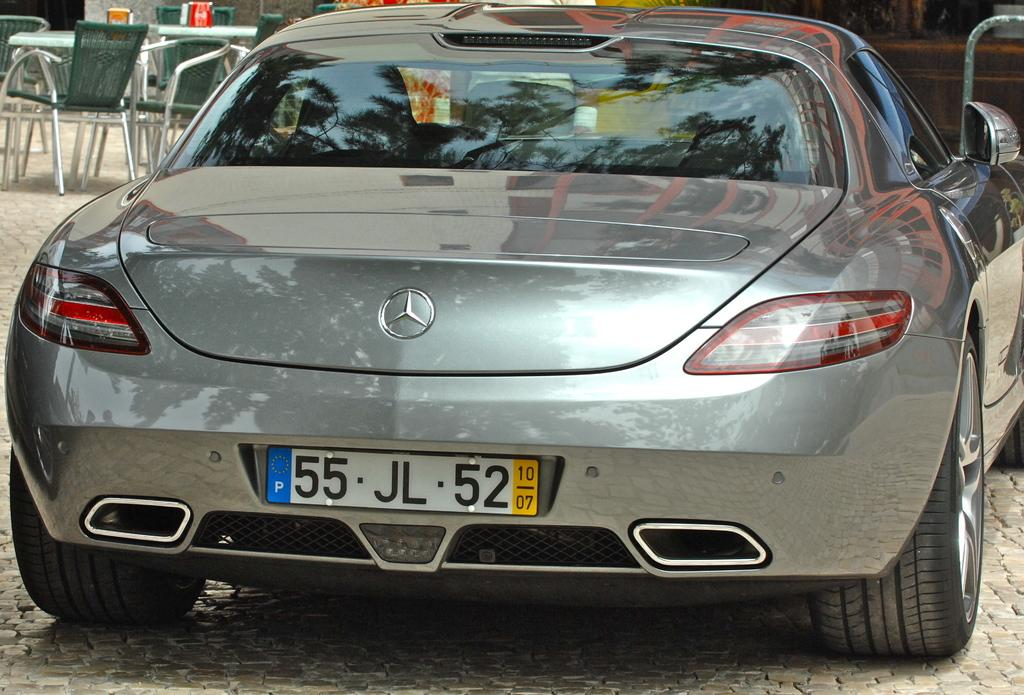What is the main subject of the image? There is a car on the ground in the image. What can be seen in the background of the image? There are tables, chairs, and other objects visible in the background of the image. How many credits can be seen on the car in the image? There are no credits visible on the car in the image. What type of houses are present in the image? There are no houses present in the image; it features a car on the ground and objects in the background. 